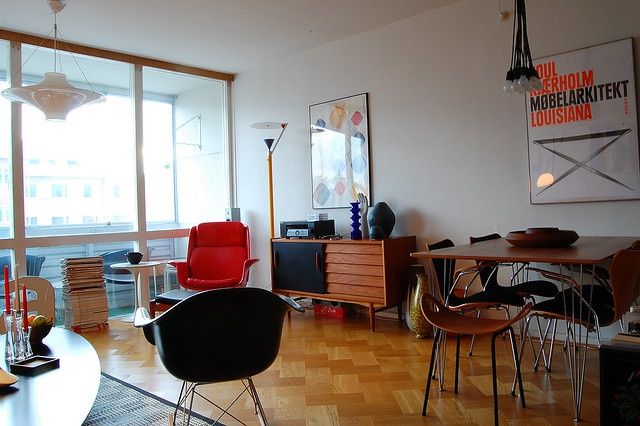Describe the objects in this image and their specific colors. I can see chair in darkgray, black, tan, and white tones, dining table in darkgray, black, gray, and maroon tones, dining table in darkgray, white, lightblue, and gray tones, chair in darkgray, black, gray, and maroon tones, and chair in darkgray, maroon, white, and brown tones in this image. 